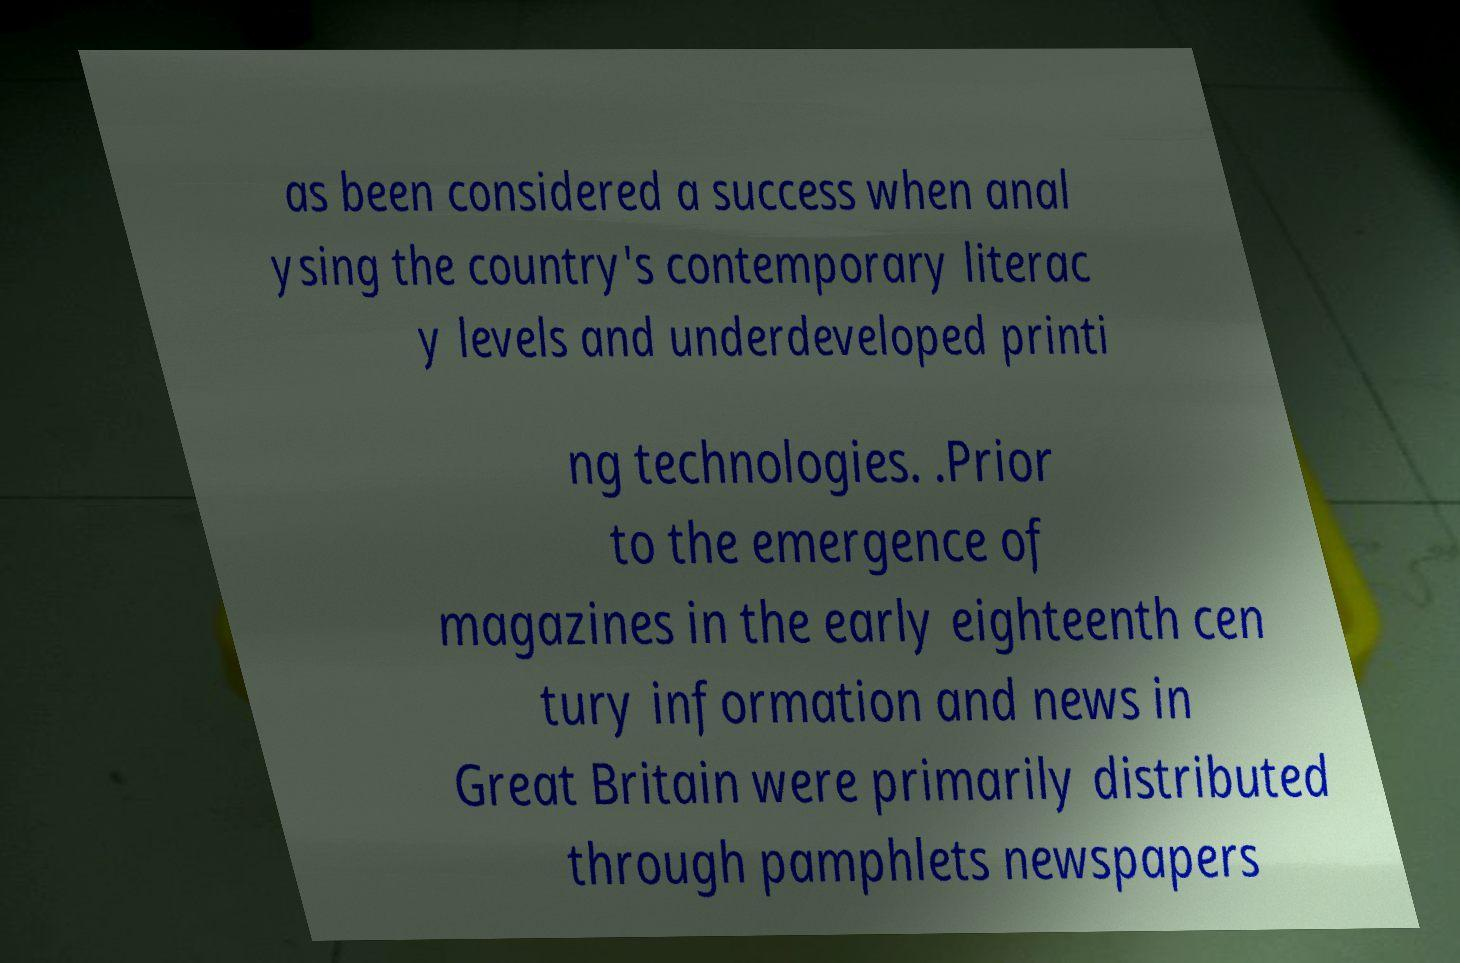I need the written content from this picture converted into text. Can you do that? as been considered a success when anal ysing the country's contemporary literac y levels and underdeveloped printi ng technologies. .Prior to the emergence of magazines in the early eighteenth cen tury information and news in Great Britain were primarily distributed through pamphlets newspapers 